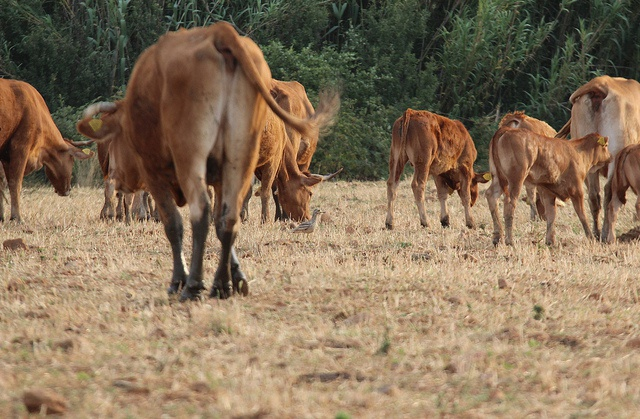Describe the objects in this image and their specific colors. I can see cow in darkgreen, maroon, gray, and black tones, cow in darkgreen, gray, brown, and maroon tones, cow in darkgreen, maroon, gray, and brown tones, cow in darkgreen, maroon, brown, and salmon tones, and cow in darkgreen, gray, tan, and maroon tones in this image. 